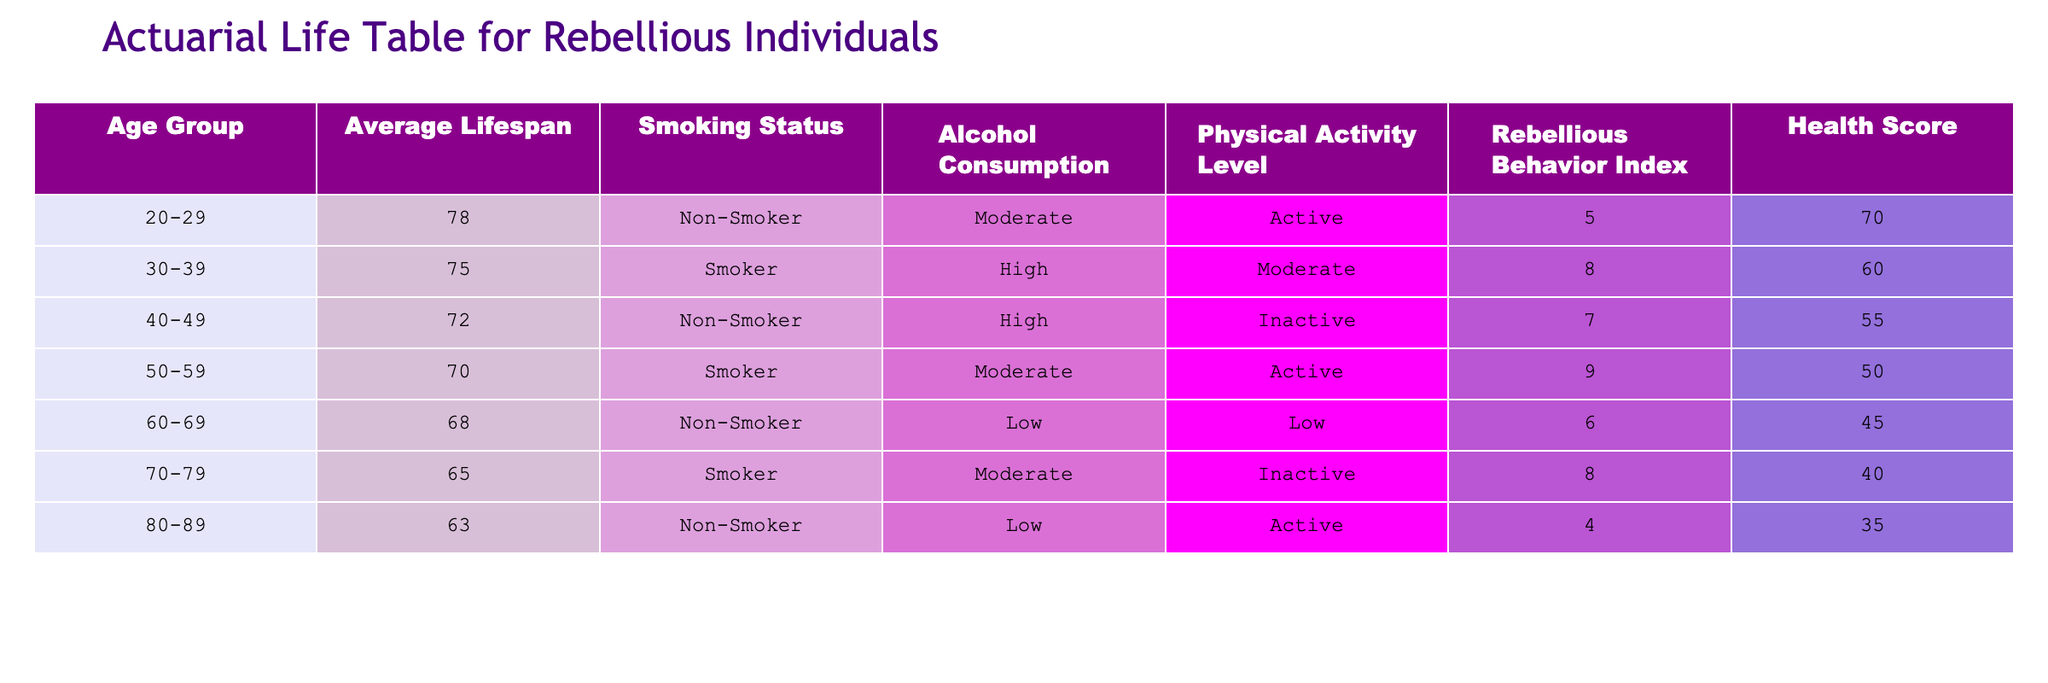What is the average lifespan of individuals aged 20-29? From the table, we can see that the average lifespan for the age group 20-29 is given directly as 78.
Answer: 78 How many age groups are listed in the table? The table contains data for a total of 8 different age groups: 20-29, 30-39, 40-49, 50-59, 60-69, 70-79, and 80-89.
Answer: 8 Is it true that individuals who are non-smokers tend to have a higher average lifespan than smokers in the 50-59 age group? In the 50-59 age group, smokers have an average lifespan of 70 while non-smokers in the 40-49 age group have an average lifespan of 72. Therefore, smokers do not have a higher lifespan in this context.
Answer: No What is the difference in average lifespan between the 30-39 age group and the 60-69 age group? The average lifespan for the 30-39 age group is 75 and for the 60-69 age group it is 68. The difference is 75 - 68 = 7 years.
Answer: 7 Which age group has the lowest health score, and what is that score? Looking at the health score column, the age group 80-89 has the lowest health score of 35.
Answer: 35 What is the average lifespan of individuals who actively engage in physical activity across all age groups? Only the age groups with an 'Active' physical activity level are 20-29, 50-59, and 80-89. Their lifespans are 78, 70, and 63 respectively. The average lifespan is (78 + 70 + 63) / 3 = 70.33, so we round it to 70 when considering whole numbers.
Answer: 70 Do rebellious individuals aged 40-49 who do not smoke have a higher health score than those who smoke at age 30-39? The health score for the 40-49 age group (non-smokers) is 55, while the health score for the 30-39 age group (smokers) is 60. Therefore, non-smokers at 40-49 do not have a higher score.
Answer: No What is the average rebellious behavior index for smokers versus non-smokers throughout all age groups? The rebellious behavior indices of smokers are 8, 9, and 8 for age groups 30-39, 50-59, and 70-79 respectively, averaging (8 + 9 + 8) / 3 = 8.33, rounded to 8. Non-smokers have indices 5, 7, 6, and 4 for age groups 20-29, 40-49, 60-69, and 80-89 respectively, averaging (5 + 7 + 6 + 4) / 4 = 5.5. Smokers have a higher average rebellious index.
Answer: Smokers 8, Non-Smokers 5.5 What group exhibits the highest alcohol consumption level, and what is their average lifespan? The highest alcohol consumption level is marked 'High', which applies to the age groups 30-39 (smoker) and 40-49 (non-smoker). The average lifespan of the 30-39 group is 75, and that of the 40-49 group is 72. Therefore, the group with the highest average lifespan at this level is 30-39.
Answer: 75 